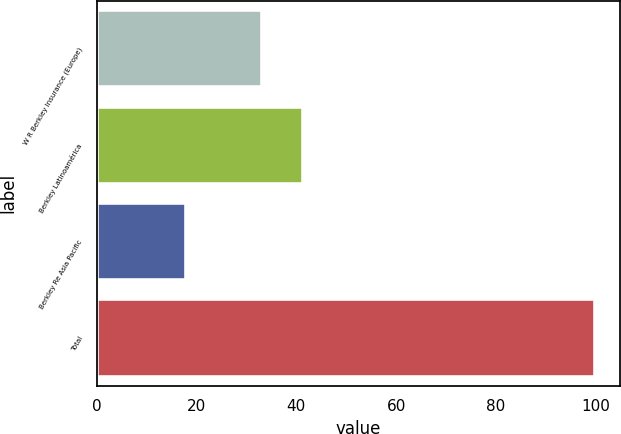Convert chart to OTSL. <chart><loc_0><loc_0><loc_500><loc_500><bar_chart><fcel>W R Berkley Insurance (Europe)<fcel>Berkley Latinoamérica<fcel>Berkley Re Asia Pacific<fcel>Total<nl><fcel>33.2<fcel>41.42<fcel>17.8<fcel>100<nl></chart> 